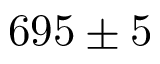<formula> <loc_0><loc_0><loc_500><loc_500>6 9 5 \pm 5</formula> 